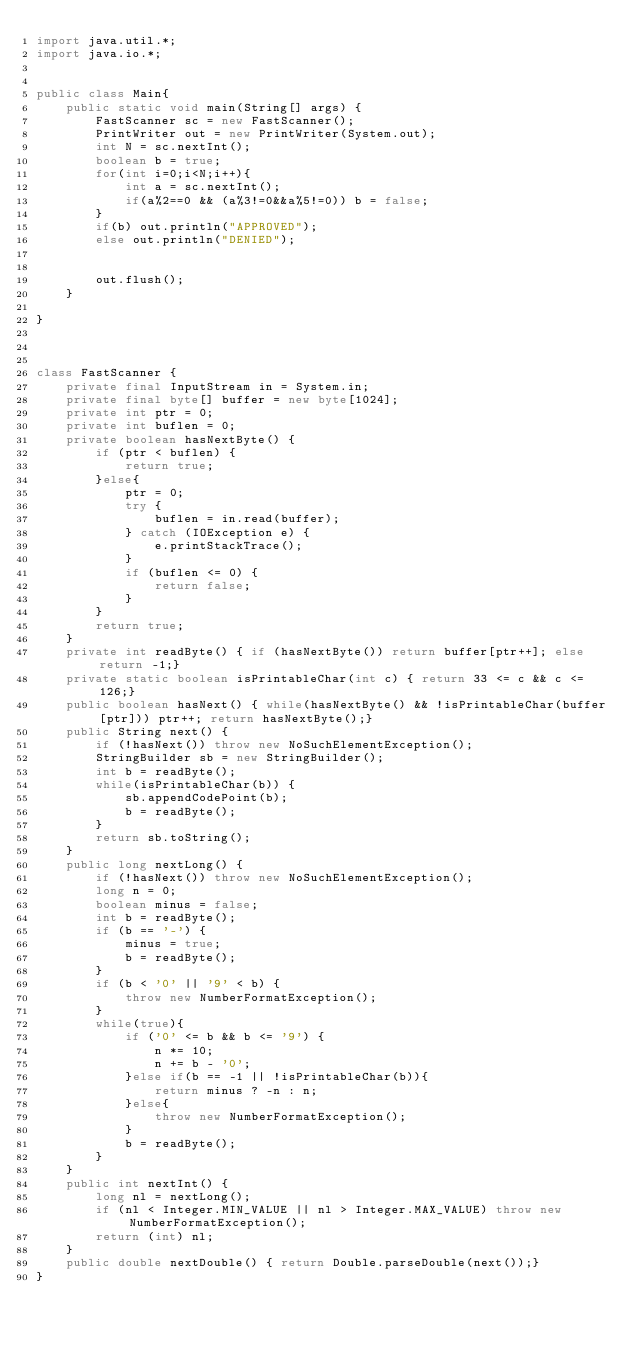Convert code to text. <code><loc_0><loc_0><loc_500><loc_500><_Java_>import java.util.*;
import java.io.*;


public class Main{
    public static void main(String[] args) {
        FastScanner sc = new FastScanner();
        PrintWriter out = new PrintWriter(System.out);
        int N = sc.nextInt();
        boolean b = true;
        for(int i=0;i<N;i++){
            int a = sc.nextInt();
            if(a%2==0 && (a%3!=0&&a%5!=0)) b = false;
        }
        if(b) out.println("APPROVED");
        else out.println("DENIED");


        out.flush();
    }

}



class FastScanner {
    private final InputStream in = System.in;
    private final byte[] buffer = new byte[1024];
    private int ptr = 0;
    private int buflen = 0;
    private boolean hasNextByte() {
        if (ptr < buflen) {
            return true;
        }else{
            ptr = 0;
            try {
                buflen = in.read(buffer);
            } catch (IOException e) {
                e.printStackTrace();
            }
            if (buflen <= 0) {
                return false;
            }
        }
        return true;
    }
    private int readByte() { if (hasNextByte()) return buffer[ptr++]; else return -1;}
    private static boolean isPrintableChar(int c) { return 33 <= c && c <= 126;}
    public boolean hasNext() { while(hasNextByte() && !isPrintableChar(buffer[ptr])) ptr++; return hasNextByte();}
    public String next() {
        if (!hasNext()) throw new NoSuchElementException();
        StringBuilder sb = new StringBuilder();
        int b = readByte();
        while(isPrintableChar(b)) {
            sb.appendCodePoint(b);
            b = readByte();
        }
        return sb.toString();
    }
    public long nextLong() {
        if (!hasNext()) throw new NoSuchElementException();
        long n = 0;
        boolean minus = false;
        int b = readByte();
        if (b == '-') {
            minus = true;
            b = readByte();
        }
        if (b < '0' || '9' < b) {
            throw new NumberFormatException();
        }
        while(true){
            if ('0' <= b && b <= '9') {
                n *= 10;
                n += b - '0';
            }else if(b == -1 || !isPrintableChar(b)){
                return minus ? -n : n;
            }else{
                throw new NumberFormatException();
            }
            b = readByte();
        }
    }
    public int nextInt() {
        long nl = nextLong();
        if (nl < Integer.MIN_VALUE || nl > Integer.MAX_VALUE) throw new NumberFormatException();
        return (int) nl;
    }
    public double nextDouble() { return Double.parseDouble(next());}
}
</code> 